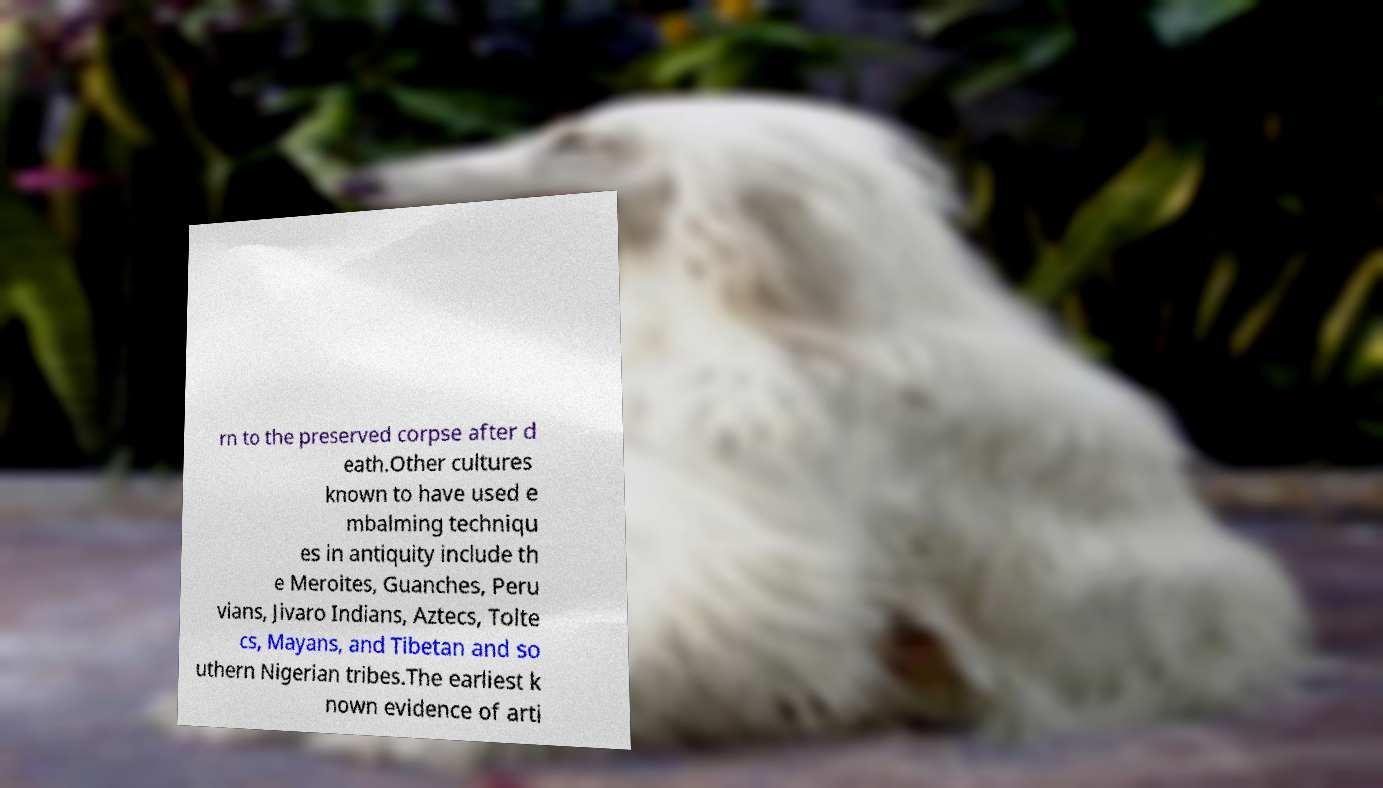Please read and relay the text visible in this image. What does it say? rn to the preserved corpse after d eath.Other cultures known to have used e mbalming techniqu es in antiquity include th e Meroites, Guanches, Peru vians, Jivaro Indians, Aztecs, Tolte cs, Mayans, and Tibetan and so uthern Nigerian tribes.The earliest k nown evidence of arti 